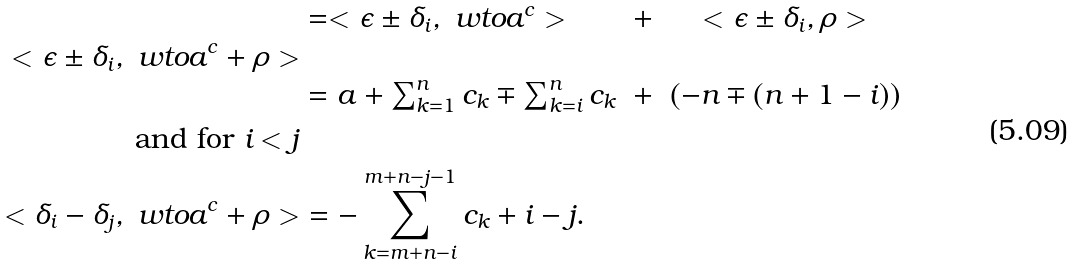<formula> <loc_0><loc_0><loc_500><loc_500>< \epsilon \pm \delta _ { i } , \ w t o a ^ { c } + \rho > & \begin{array} [ t ] { l c c } = < \epsilon \pm \delta _ { i } , \ w t o a ^ { c } > & + & < \epsilon \pm \delta _ { i } , \rho > \\ \\ = a + \sum _ { k = 1 } ^ { n } c _ { k } \mp \sum _ { k = i } ^ { n } c _ { k } & + & ( - n \mp ( n + 1 - i ) ) \end{array} \\ \text { and for } i < j \\ < \delta _ { i } - \delta _ { j } , \ w t o a ^ { c } + \rho > & = - \sum _ { k = m + n - i } ^ { m + n - j - 1 } c _ { k } + i - j .</formula> 